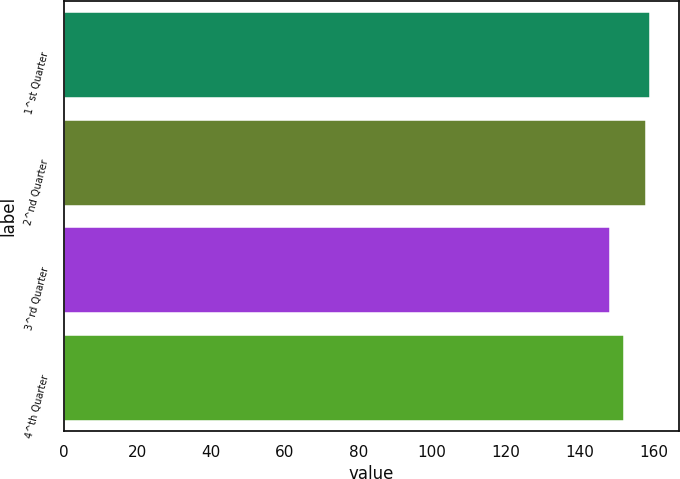Convert chart to OTSL. <chart><loc_0><loc_0><loc_500><loc_500><bar_chart><fcel>1^st Quarter<fcel>2^nd Quarter<fcel>3^rd Quarter<fcel>4^th Quarter<nl><fcel>158.95<fcel>157.92<fcel>148.23<fcel>152.16<nl></chart> 